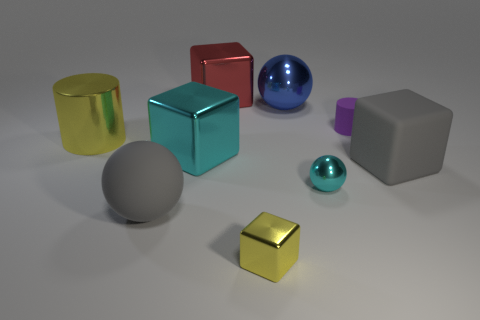Are there an equal number of purple cylinders that are to the left of the tiny cyan ball and large yellow metallic cylinders that are on the right side of the small purple rubber thing?
Ensure brevity in your answer.  Yes. What material is the large object in front of the gray thing on the right side of the small matte object?
Your answer should be compact. Rubber. How many things are big gray things or large yellow cylinders?
Provide a short and direct response. 3. There is a metallic object that is the same color as the metal cylinder; what is its size?
Offer a very short reply. Small. Are there fewer tiny yellow matte cubes than purple objects?
Your answer should be compact. Yes. What size is the purple object that is the same material as the big gray ball?
Offer a very short reply. Small. How big is the cyan ball?
Your response must be concise. Small. What is the shape of the large blue shiny thing?
Make the answer very short. Sphere. There is a large ball that is in front of the cyan shiny cube; does it have the same color as the rubber block?
Make the answer very short. Yes. There is a yellow object that is the same shape as the big cyan metal thing; what is its size?
Keep it short and to the point. Small. 